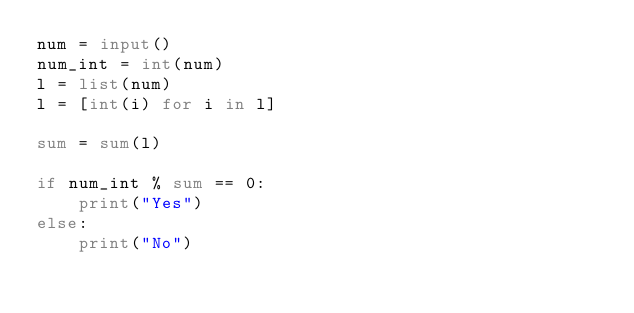Convert code to text. <code><loc_0><loc_0><loc_500><loc_500><_Python_>num = input()
num_int = int(num)
l = list(num)
l = [int(i) for i in l]

sum = sum(l)

if num_int % sum == 0:
    print("Yes")
else:
    print("No")</code> 